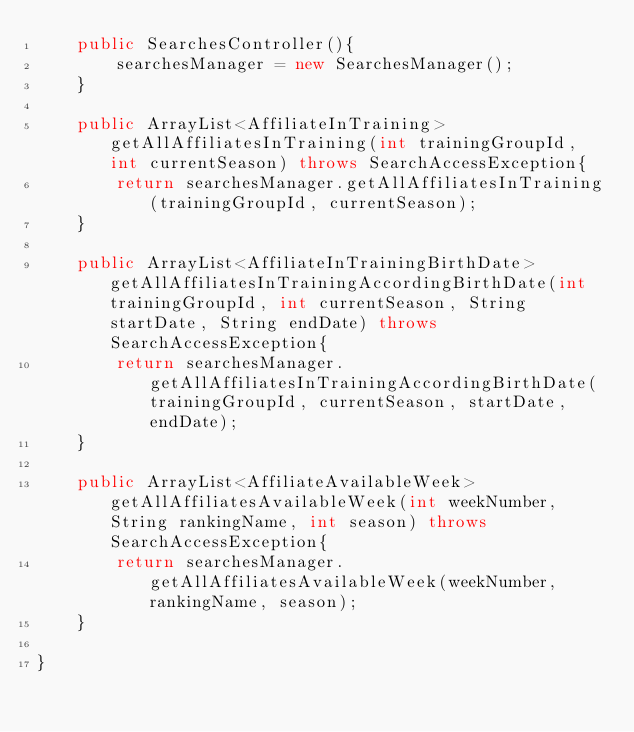Convert code to text. <code><loc_0><loc_0><loc_500><loc_500><_Java_>    public SearchesController(){
        searchesManager = new SearchesManager();
    }

    public ArrayList<AffiliateInTraining> getAllAffiliatesInTraining(int trainingGroupId, int currentSeason) throws SearchAccessException{
        return searchesManager.getAllAffiliatesInTraining(trainingGroupId, currentSeason);
    }

    public ArrayList<AffiliateInTrainingBirthDate> getAllAffiliatesInTrainingAccordingBirthDate(int trainingGroupId, int currentSeason, String startDate, String endDate) throws SearchAccessException{
        return searchesManager.getAllAffiliatesInTrainingAccordingBirthDate(trainingGroupId, currentSeason, startDate, endDate);
    }

    public ArrayList<AffiliateAvailableWeek> getAllAffiliatesAvailableWeek(int weekNumber, String rankingName, int season) throws SearchAccessException{
        return searchesManager.getAllAffiliatesAvailableWeek(weekNumber, rankingName, season);
    }

}
</code> 